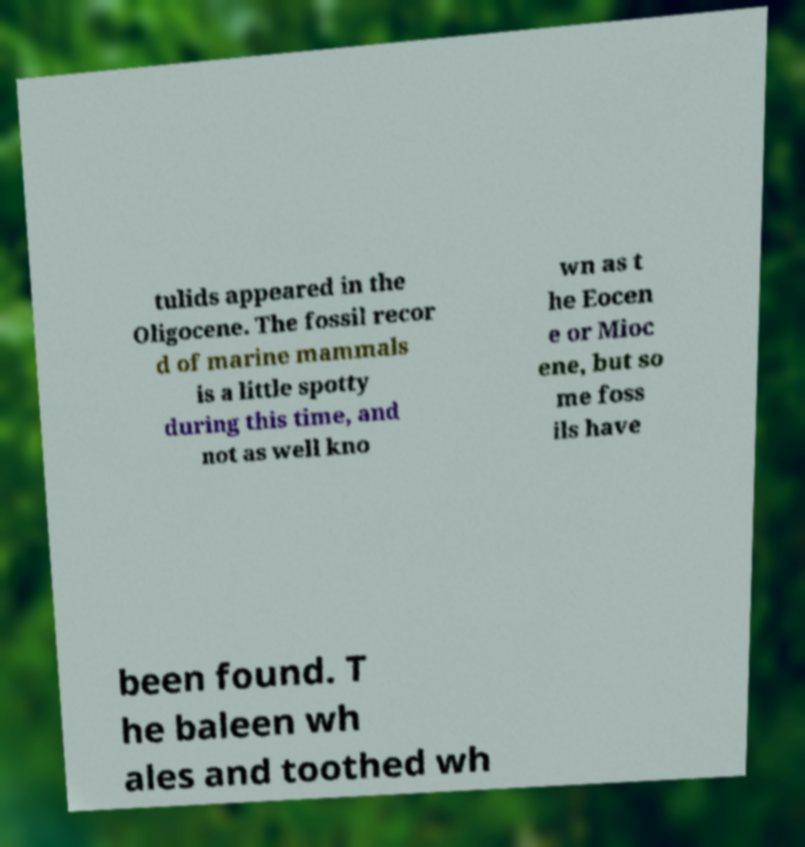Could you extract and type out the text from this image? tulids appeared in the Oligocene. The fossil recor d of marine mammals is a little spotty during this time, and not as well kno wn as t he Eocen e or Mioc ene, but so me foss ils have been found. T he baleen wh ales and toothed wh 